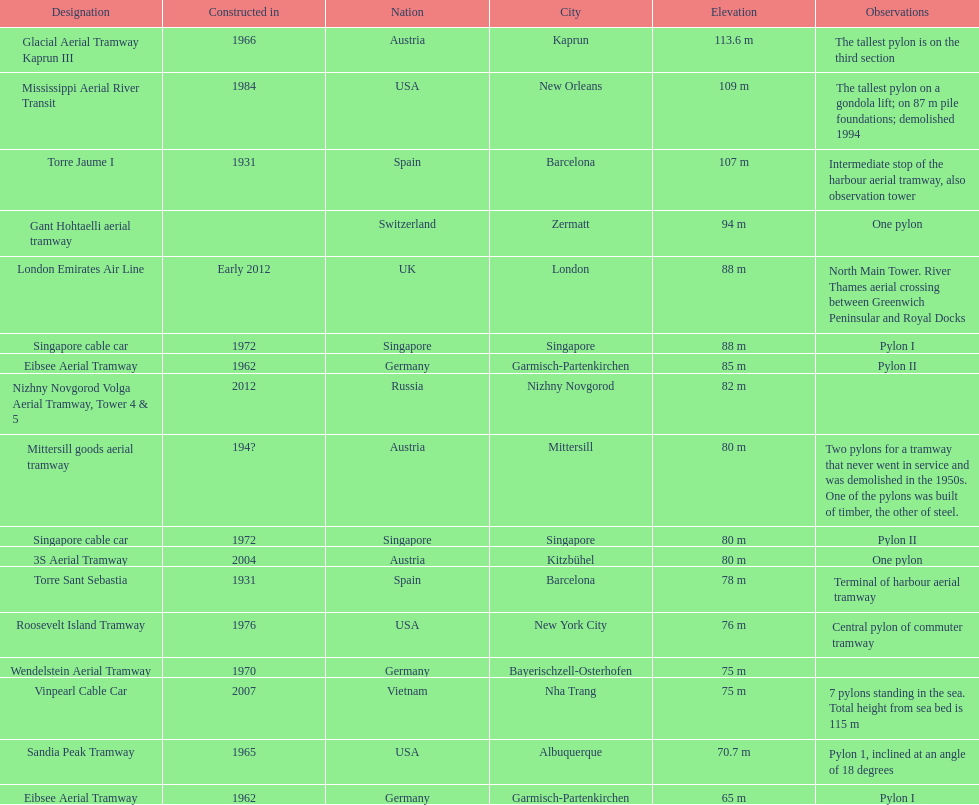What is the total number of pylons listed? 17. 